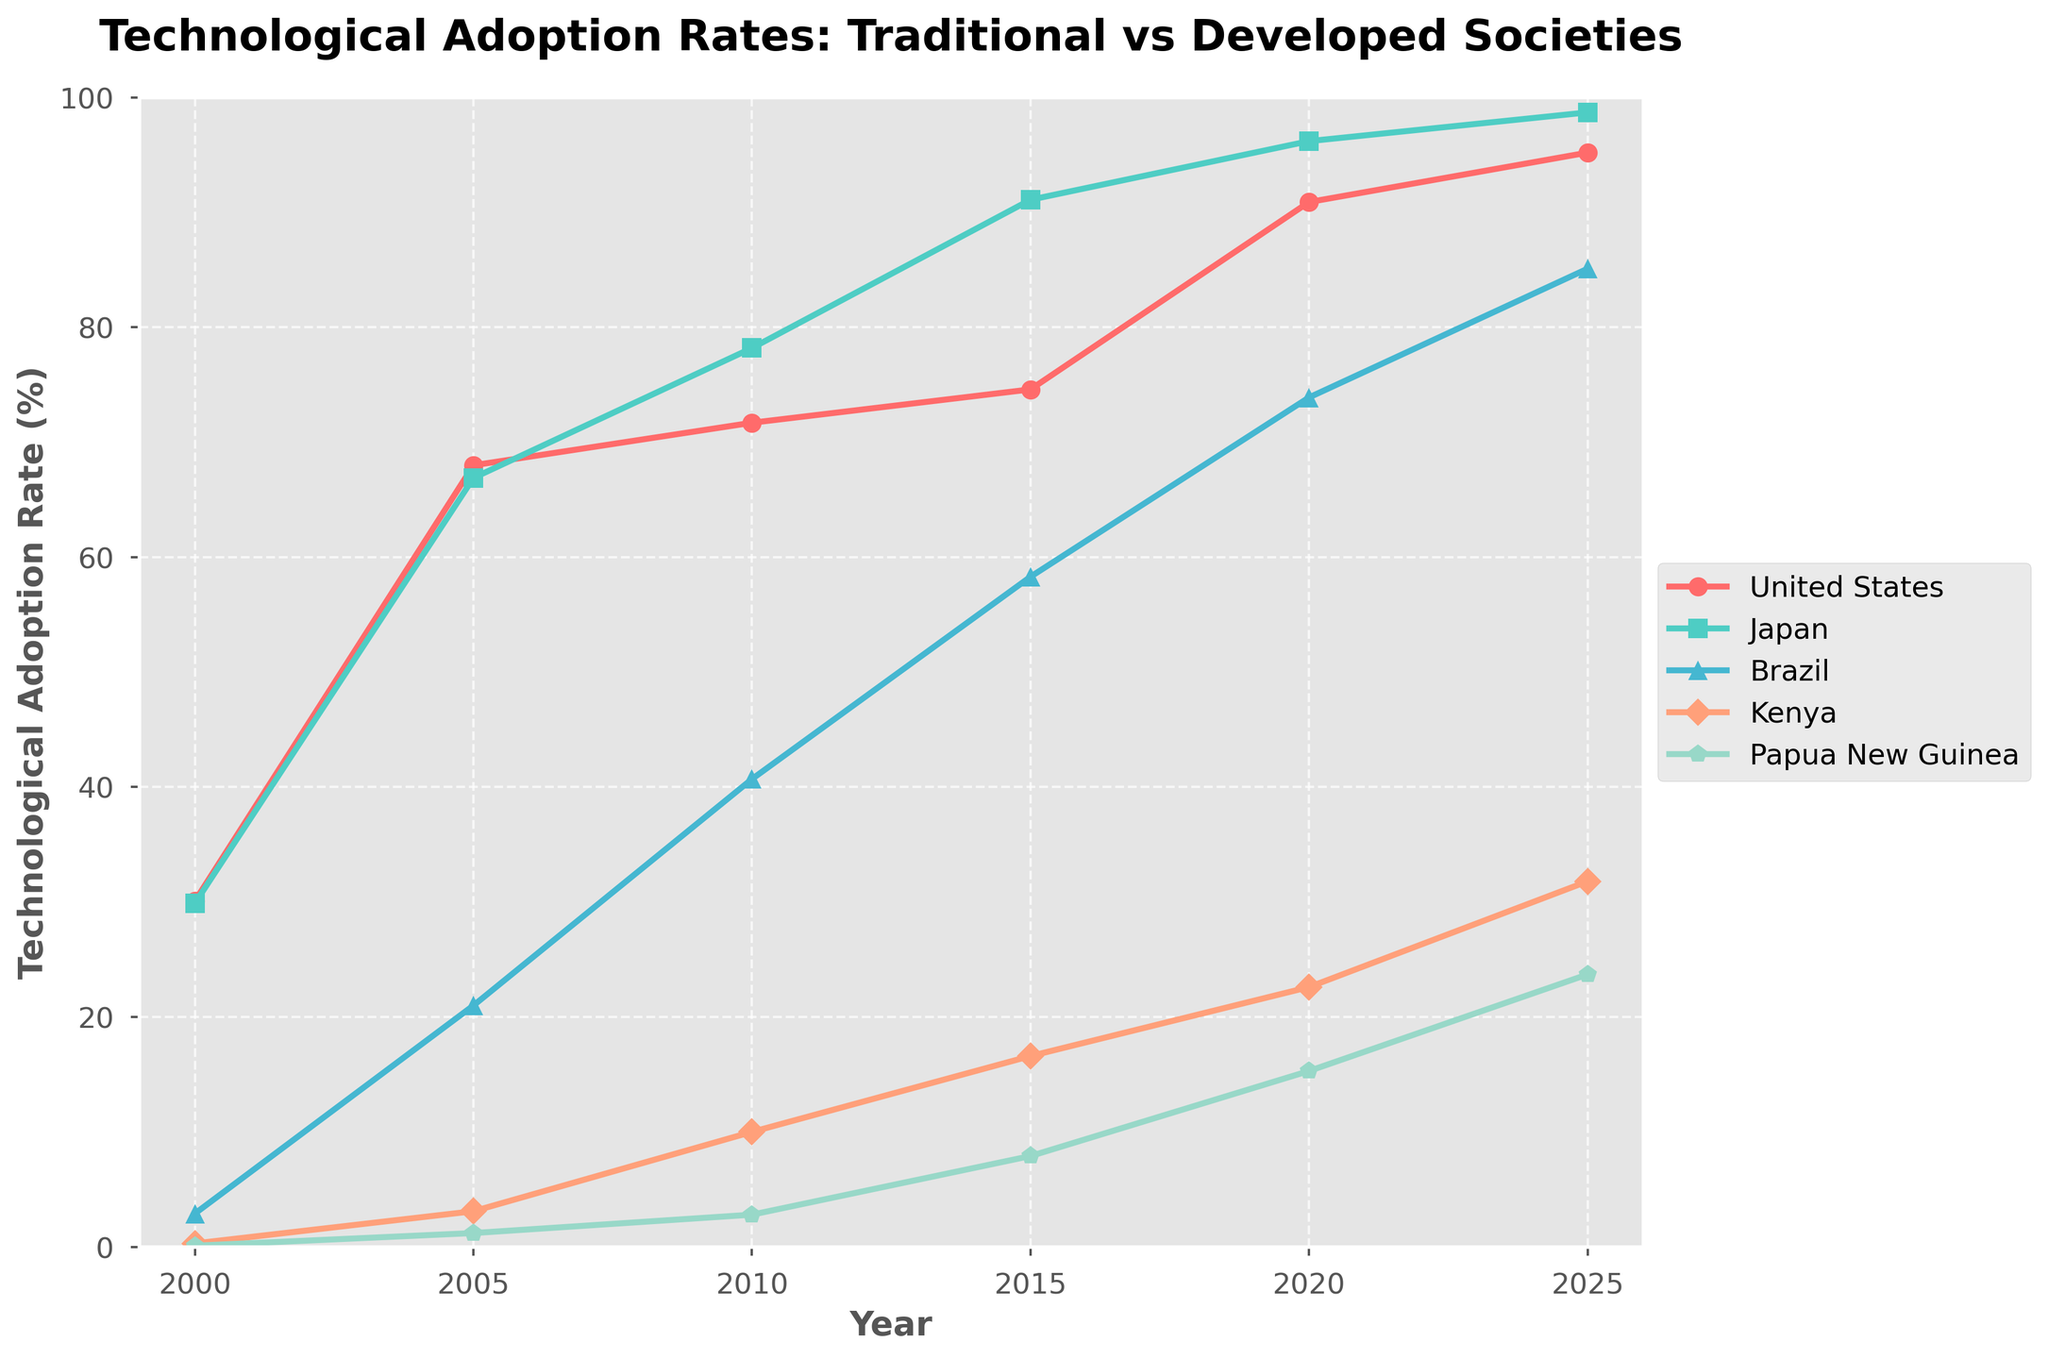What is the technological adoption rate in Kenya in 2015? Look at the line representing Kenya (in orange) on the chart and find the point corresponding to the year 2015. Read the value directly from the y-axis.
Answer: 16.6 Which country shows the highest technological adoption rate in 2025? Identify and compare the technological adoption rates for each country in the year 2025 on the chart. The highest value is for Japan.
Answer: Japan By how much did the technological adoption rate in Brazil increase between 2005 and 2020? Locate Brazil's adoption rates for 2005 (21.0) and 2020 (73.9). Subtract the earlier value from the later value: 73.9 - 21.0.
Answer: 52.9 How does the technological adoption rate in Papua New Guinea in 2020 compare to that in Kenya in 2010? Find the points for Papua New Guinea in 2020 (15.3) and Kenya in 2010 (10.0). Compare the values; note that 15.3 is greater than 10.
Answer: Papua New Guinea has a higher rate What is the average technological adoption rate across all countries in 2010? Sum the respective values for each country in 2010 (71.7 + 78.2 + 40.7 + 10.0 + 2.8), then divide by the number of countries (5). Calculation: (71.7 + 78.2 + 40.7 + 10.0 + 2.8) / 5.
Answer: 40.68 Which country has improved its technological adoption rate by the largest percentage from 2000 to 2025? Calculate the percentage increase for each country: ((rate in 2025 - rate in 2000) / rate in 2000) * 100. Identify the largest value. Papua New Guinea increased from 0.1% to 23.7%, which is a ((23.7 - 0.1) / 0.1) * 100 = 23,600% increase.
Answer: Papua New Guinea What changes can be observed in the technological adoption rates of Japan and the United States between 2000 and 2025? Locate the points for 2000 and 2025 for both Japan and the United States. Note that Japan increases from 29.9% to 98.7%, while the United States increases from 30.1% to 95.2%. Both countries see significant growth, with Japan consistently having a slightly higher rate in later years.
Answer: Significant increase in both countries, with Japan slightly higher Which country had the lowest technological adoption rate in 2020? Compare the technological adoption rates for each country in 2020. Papua New Guinea has the lowest rate at 15.3%.
Answer: Papua New Guinea By how much did the technological adoption rate in the United States grow from 2000 to 2025? Look at the United States' rates for 2000 (30.1) and 2025 (95.2). Calculate the difference: 95.2 - 30.1.
Answer: 65.1 What was the technological adoption rate in Brazil in 2015, and how does this compare to Kenya's adoption rate in the same year? Locate Brazil's rate in 2015 (58.3) and Kenya's rate in 2015 (16.6). Compare the two values, noting that Brazil's rate is significantly higher.
Answer: Brazil 58.3, much higher than Kenya 16.6 